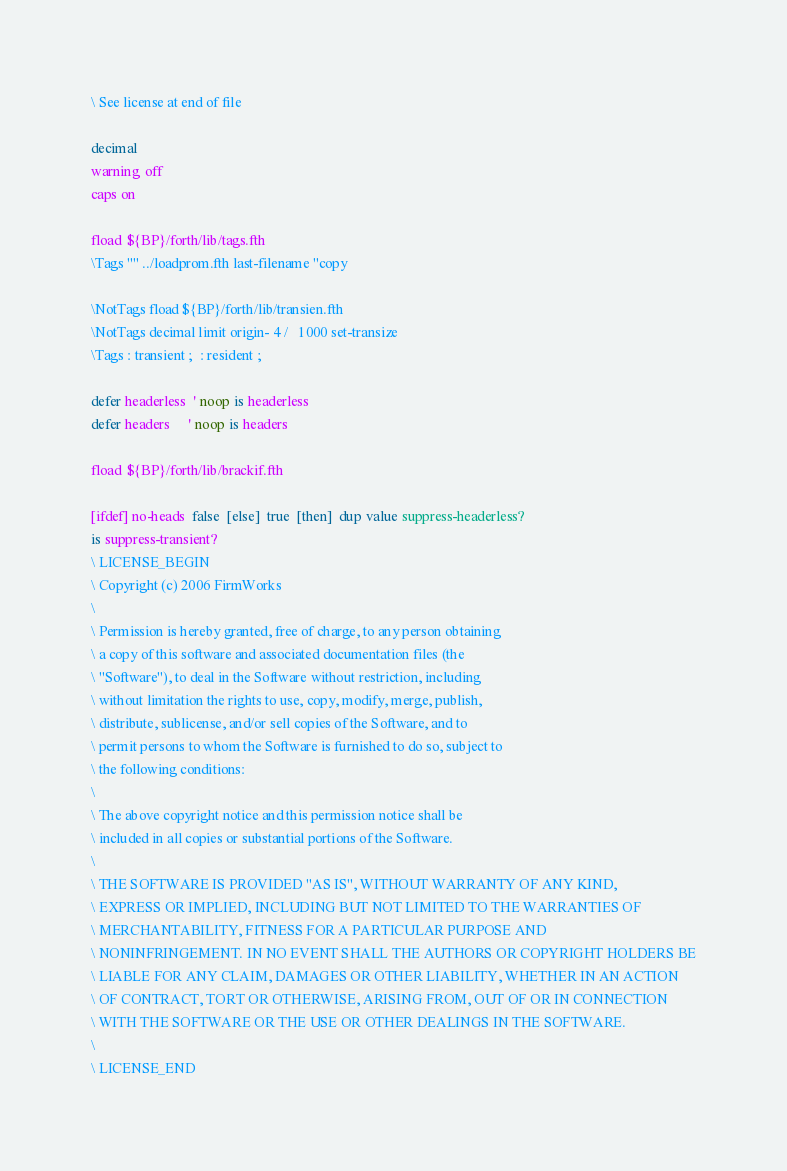<code> <loc_0><loc_0><loc_500><loc_500><_Forth_>\ See license at end of file

decimal
warning off
caps on

fload ${BP}/forth/lib/tags.fth
\Tags "" ../loadprom.fth last-filename "copy

\NotTags fload ${BP}/forth/lib/transien.fth
\NotTags decimal limit origin- 4 /   1000 set-transize
\Tags : transient ;  : resident ;

defer headerless  ' noop is headerless
defer headers     ' noop is headers

fload ${BP}/forth/lib/brackif.fth

[ifdef] no-heads  false  [else]  true  [then]  dup value suppress-headerless?
is suppress-transient?
\ LICENSE_BEGIN
\ Copyright (c) 2006 FirmWorks
\ 
\ Permission is hereby granted, free of charge, to any person obtaining
\ a copy of this software and associated documentation files (the
\ "Software"), to deal in the Software without restriction, including
\ without limitation the rights to use, copy, modify, merge, publish,
\ distribute, sublicense, and/or sell copies of the Software, and to
\ permit persons to whom the Software is furnished to do so, subject to
\ the following conditions:
\ 
\ The above copyright notice and this permission notice shall be
\ included in all copies or substantial portions of the Software.
\ 
\ THE SOFTWARE IS PROVIDED "AS IS", WITHOUT WARRANTY OF ANY KIND,
\ EXPRESS OR IMPLIED, INCLUDING BUT NOT LIMITED TO THE WARRANTIES OF
\ MERCHANTABILITY, FITNESS FOR A PARTICULAR PURPOSE AND
\ NONINFRINGEMENT. IN NO EVENT SHALL THE AUTHORS OR COPYRIGHT HOLDERS BE
\ LIABLE FOR ANY CLAIM, DAMAGES OR OTHER LIABILITY, WHETHER IN AN ACTION
\ OF CONTRACT, TORT OR OTHERWISE, ARISING FROM, OUT OF OR IN CONNECTION
\ WITH THE SOFTWARE OR THE USE OR OTHER DEALINGS IN THE SOFTWARE.
\
\ LICENSE_END
</code> 